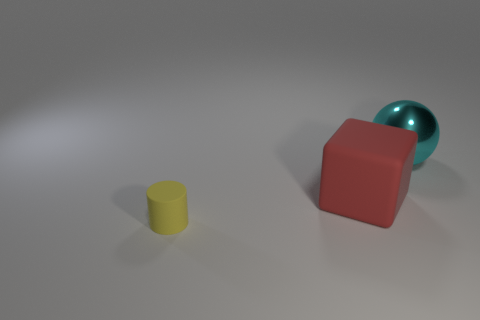Add 2 tiny shiny cubes. How many objects exist? 5 Subtract all cubes. How many objects are left? 2 Add 3 small yellow rubber objects. How many small yellow rubber objects exist? 4 Subtract 0 cyan blocks. How many objects are left? 3 Subtract all big matte things. Subtract all tiny gray metallic spheres. How many objects are left? 2 Add 1 red rubber blocks. How many red rubber blocks are left? 2 